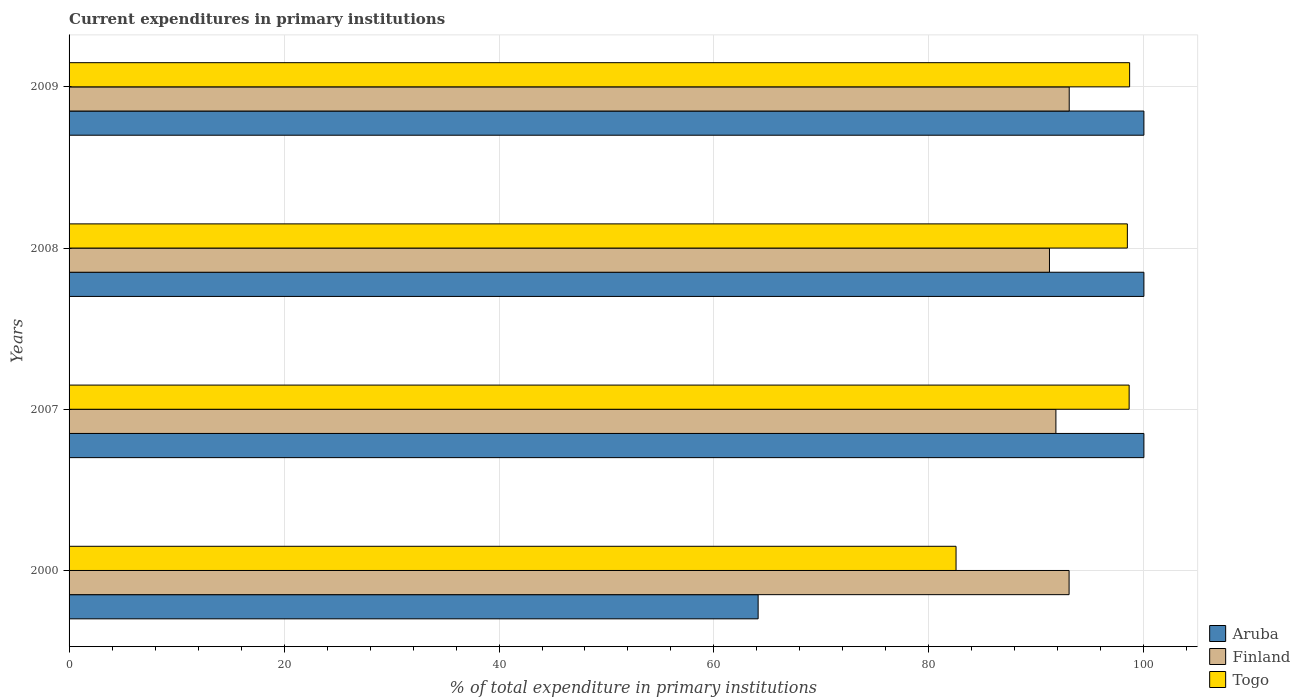Are the number of bars on each tick of the Y-axis equal?
Offer a terse response. Yes. In how many cases, is the number of bars for a given year not equal to the number of legend labels?
Offer a very short reply. 0. Across all years, what is the maximum current expenditures in primary institutions in Aruba?
Your answer should be very brief. 100. Across all years, what is the minimum current expenditures in primary institutions in Aruba?
Keep it short and to the point. 64.11. What is the total current expenditures in primary institutions in Finland in the graph?
Offer a terse response. 369.12. What is the difference between the current expenditures in primary institutions in Aruba in 2007 and that in 2009?
Offer a terse response. 0. What is the difference between the current expenditures in primary institutions in Finland in 2000 and the current expenditures in primary institutions in Aruba in 2008?
Your response must be concise. -6.96. What is the average current expenditures in primary institutions in Togo per year?
Your answer should be compact. 94.57. In the year 2007, what is the difference between the current expenditures in primary institutions in Aruba and current expenditures in primary institutions in Finland?
Your answer should be very brief. 8.19. What is the ratio of the current expenditures in primary institutions in Togo in 2000 to that in 2008?
Provide a short and direct response. 0.84. Is the difference between the current expenditures in primary institutions in Aruba in 2000 and 2009 greater than the difference between the current expenditures in primary institutions in Finland in 2000 and 2009?
Your answer should be compact. No. What is the difference between the highest and the second highest current expenditures in primary institutions in Togo?
Your answer should be compact. 0.04. What is the difference between the highest and the lowest current expenditures in primary institutions in Togo?
Ensure brevity in your answer.  16.15. In how many years, is the current expenditures in primary institutions in Aruba greater than the average current expenditures in primary institutions in Aruba taken over all years?
Provide a succinct answer. 3. What does the 1st bar from the top in 2008 represents?
Keep it short and to the point. Togo. What does the 2nd bar from the bottom in 2008 represents?
Your answer should be very brief. Finland. Is it the case that in every year, the sum of the current expenditures in primary institutions in Togo and current expenditures in primary institutions in Finland is greater than the current expenditures in primary institutions in Aruba?
Make the answer very short. Yes. How many bars are there?
Offer a very short reply. 12. How many years are there in the graph?
Provide a short and direct response. 4. What is the difference between two consecutive major ticks on the X-axis?
Keep it short and to the point. 20. Are the values on the major ticks of X-axis written in scientific E-notation?
Ensure brevity in your answer.  No. Where does the legend appear in the graph?
Your response must be concise. Bottom right. How many legend labels are there?
Offer a terse response. 3. What is the title of the graph?
Offer a terse response. Current expenditures in primary institutions. Does "United States" appear as one of the legend labels in the graph?
Your answer should be compact. No. What is the label or title of the X-axis?
Provide a short and direct response. % of total expenditure in primary institutions. What is the % of total expenditure in primary institutions in Aruba in 2000?
Offer a very short reply. 64.11. What is the % of total expenditure in primary institutions of Finland in 2000?
Keep it short and to the point. 93.04. What is the % of total expenditure in primary institutions of Togo in 2000?
Your answer should be compact. 82.52. What is the % of total expenditure in primary institutions of Aruba in 2007?
Your response must be concise. 100. What is the % of total expenditure in primary institutions in Finland in 2007?
Your response must be concise. 91.81. What is the % of total expenditure in primary institutions in Togo in 2007?
Give a very brief answer. 98.63. What is the % of total expenditure in primary institutions in Aruba in 2008?
Provide a succinct answer. 100. What is the % of total expenditure in primary institutions in Finland in 2008?
Offer a terse response. 91.21. What is the % of total expenditure in primary institutions in Togo in 2008?
Your answer should be very brief. 98.46. What is the % of total expenditure in primary institutions in Aruba in 2009?
Your response must be concise. 100. What is the % of total expenditure in primary institutions of Finland in 2009?
Give a very brief answer. 93.05. What is the % of total expenditure in primary institutions in Togo in 2009?
Your answer should be very brief. 98.67. Across all years, what is the maximum % of total expenditure in primary institutions in Finland?
Offer a terse response. 93.05. Across all years, what is the maximum % of total expenditure in primary institutions in Togo?
Keep it short and to the point. 98.67. Across all years, what is the minimum % of total expenditure in primary institutions of Aruba?
Ensure brevity in your answer.  64.11. Across all years, what is the minimum % of total expenditure in primary institutions in Finland?
Give a very brief answer. 91.21. Across all years, what is the minimum % of total expenditure in primary institutions of Togo?
Offer a very short reply. 82.52. What is the total % of total expenditure in primary institutions of Aruba in the graph?
Your answer should be compact. 364.11. What is the total % of total expenditure in primary institutions of Finland in the graph?
Offer a very short reply. 369.12. What is the total % of total expenditure in primary institutions in Togo in the graph?
Ensure brevity in your answer.  378.28. What is the difference between the % of total expenditure in primary institutions in Aruba in 2000 and that in 2007?
Your answer should be very brief. -35.89. What is the difference between the % of total expenditure in primary institutions in Finland in 2000 and that in 2007?
Your answer should be very brief. 1.23. What is the difference between the % of total expenditure in primary institutions of Togo in 2000 and that in 2007?
Keep it short and to the point. -16.11. What is the difference between the % of total expenditure in primary institutions of Aruba in 2000 and that in 2008?
Give a very brief answer. -35.89. What is the difference between the % of total expenditure in primary institutions in Finland in 2000 and that in 2008?
Your answer should be very brief. 1.83. What is the difference between the % of total expenditure in primary institutions in Togo in 2000 and that in 2008?
Give a very brief answer. -15.94. What is the difference between the % of total expenditure in primary institutions in Aruba in 2000 and that in 2009?
Your response must be concise. -35.89. What is the difference between the % of total expenditure in primary institutions of Finland in 2000 and that in 2009?
Provide a short and direct response. -0.01. What is the difference between the % of total expenditure in primary institutions of Togo in 2000 and that in 2009?
Offer a terse response. -16.15. What is the difference between the % of total expenditure in primary institutions in Finland in 2007 and that in 2008?
Make the answer very short. 0.6. What is the difference between the % of total expenditure in primary institutions of Togo in 2007 and that in 2008?
Provide a succinct answer. 0.17. What is the difference between the % of total expenditure in primary institutions of Aruba in 2007 and that in 2009?
Make the answer very short. 0. What is the difference between the % of total expenditure in primary institutions of Finland in 2007 and that in 2009?
Ensure brevity in your answer.  -1.24. What is the difference between the % of total expenditure in primary institutions of Togo in 2007 and that in 2009?
Provide a succinct answer. -0.04. What is the difference between the % of total expenditure in primary institutions in Finland in 2008 and that in 2009?
Ensure brevity in your answer.  -1.84. What is the difference between the % of total expenditure in primary institutions of Togo in 2008 and that in 2009?
Provide a short and direct response. -0.21. What is the difference between the % of total expenditure in primary institutions of Aruba in 2000 and the % of total expenditure in primary institutions of Finland in 2007?
Provide a succinct answer. -27.7. What is the difference between the % of total expenditure in primary institutions of Aruba in 2000 and the % of total expenditure in primary institutions of Togo in 2007?
Ensure brevity in your answer.  -34.52. What is the difference between the % of total expenditure in primary institutions of Finland in 2000 and the % of total expenditure in primary institutions of Togo in 2007?
Make the answer very short. -5.59. What is the difference between the % of total expenditure in primary institutions of Aruba in 2000 and the % of total expenditure in primary institutions of Finland in 2008?
Provide a short and direct response. -27.1. What is the difference between the % of total expenditure in primary institutions in Aruba in 2000 and the % of total expenditure in primary institutions in Togo in 2008?
Keep it short and to the point. -34.35. What is the difference between the % of total expenditure in primary institutions of Finland in 2000 and the % of total expenditure in primary institutions of Togo in 2008?
Offer a terse response. -5.42. What is the difference between the % of total expenditure in primary institutions of Aruba in 2000 and the % of total expenditure in primary institutions of Finland in 2009?
Make the answer very short. -28.94. What is the difference between the % of total expenditure in primary institutions in Aruba in 2000 and the % of total expenditure in primary institutions in Togo in 2009?
Make the answer very short. -34.56. What is the difference between the % of total expenditure in primary institutions in Finland in 2000 and the % of total expenditure in primary institutions in Togo in 2009?
Keep it short and to the point. -5.63. What is the difference between the % of total expenditure in primary institutions of Aruba in 2007 and the % of total expenditure in primary institutions of Finland in 2008?
Your response must be concise. 8.79. What is the difference between the % of total expenditure in primary institutions of Aruba in 2007 and the % of total expenditure in primary institutions of Togo in 2008?
Make the answer very short. 1.54. What is the difference between the % of total expenditure in primary institutions of Finland in 2007 and the % of total expenditure in primary institutions of Togo in 2008?
Your answer should be very brief. -6.65. What is the difference between the % of total expenditure in primary institutions of Aruba in 2007 and the % of total expenditure in primary institutions of Finland in 2009?
Your answer should be very brief. 6.95. What is the difference between the % of total expenditure in primary institutions in Aruba in 2007 and the % of total expenditure in primary institutions in Togo in 2009?
Your answer should be compact. 1.33. What is the difference between the % of total expenditure in primary institutions in Finland in 2007 and the % of total expenditure in primary institutions in Togo in 2009?
Your response must be concise. -6.86. What is the difference between the % of total expenditure in primary institutions of Aruba in 2008 and the % of total expenditure in primary institutions of Finland in 2009?
Keep it short and to the point. 6.95. What is the difference between the % of total expenditure in primary institutions of Aruba in 2008 and the % of total expenditure in primary institutions of Togo in 2009?
Make the answer very short. 1.33. What is the difference between the % of total expenditure in primary institutions in Finland in 2008 and the % of total expenditure in primary institutions in Togo in 2009?
Give a very brief answer. -7.46. What is the average % of total expenditure in primary institutions of Aruba per year?
Ensure brevity in your answer.  91.03. What is the average % of total expenditure in primary institutions in Finland per year?
Your response must be concise. 92.28. What is the average % of total expenditure in primary institutions in Togo per year?
Your answer should be very brief. 94.57. In the year 2000, what is the difference between the % of total expenditure in primary institutions in Aruba and % of total expenditure in primary institutions in Finland?
Offer a terse response. -28.93. In the year 2000, what is the difference between the % of total expenditure in primary institutions of Aruba and % of total expenditure in primary institutions of Togo?
Provide a short and direct response. -18.41. In the year 2000, what is the difference between the % of total expenditure in primary institutions in Finland and % of total expenditure in primary institutions in Togo?
Provide a short and direct response. 10.52. In the year 2007, what is the difference between the % of total expenditure in primary institutions of Aruba and % of total expenditure in primary institutions of Finland?
Provide a short and direct response. 8.19. In the year 2007, what is the difference between the % of total expenditure in primary institutions of Aruba and % of total expenditure in primary institutions of Togo?
Offer a very short reply. 1.37. In the year 2007, what is the difference between the % of total expenditure in primary institutions in Finland and % of total expenditure in primary institutions in Togo?
Offer a terse response. -6.81. In the year 2008, what is the difference between the % of total expenditure in primary institutions in Aruba and % of total expenditure in primary institutions in Finland?
Provide a succinct answer. 8.79. In the year 2008, what is the difference between the % of total expenditure in primary institutions in Aruba and % of total expenditure in primary institutions in Togo?
Your answer should be very brief. 1.54. In the year 2008, what is the difference between the % of total expenditure in primary institutions of Finland and % of total expenditure in primary institutions of Togo?
Provide a short and direct response. -7.25. In the year 2009, what is the difference between the % of total expenditure in primary institutions of Aruba and % of total expenditure in primary institutions of Finland?
Your answer should be compact. 6.95. In the year 2009, what is the difference between the % of total expenditure in primary institutions of Aruba and % of total expenditure in primary institutions of Togo?
Your response must be concise. 1.33. In the year 2009, what is the difference between the % of total expenditure in primary institutions in Finland and % of total expenditure in primary institutions in Togo?
Your answer should be very brief. -5.62. What is the ratio of the % of total expenditure in primary institutions in Aruba in 2000 to that in 2007?
Provide a succinct answer. 0.64. What is the ratio of the % of total expenditure in primary institutions in Finland in 2000 to that in 2007?
Ensure brevity in your answer.  1.01. What is the ratio of the % of total expenditure in primary institutions of Togo in 2000 to that in 2007?
Your response must be concise. 0.84. What is the ratio of the % of total expenditure in primary institutions of Aruba in 2000 to that in 2008?
Offer a very short reply. 0.64. What is the ratio of the % of total expenditure in primary institutions in Finland in 2000 to that in 2008?
Your answer should be compact. 1.02. What is the ratio of the % of total expenditure in primary institutions of Togo in 2000 to that in 2008?
Provide a succinct answer. 0.84. What is the ratio of the % of total expenditure in primary institutions of Aruba in 2000 to that in 2009?
Your answer should be compact. 0.64. What is the ratio of the % of total expenditure in primary institutions in Togo in 2000 to that in 2009?
Your answer should be very brief. 0.84. What is the ratio of the % of total expenditure in primary institutions of Aruba in 2007 to that in 2008?
Make the answer very short. 1. What is the ratio of the % of total expenditure in primary institutions of Finland in 2007 to that in 2008?
Offer a very short reply. 1.01. What is the ratio of the % of total expenditure in primary institutions in Aruba in 2007 to that in 2009?
Provide a short and direct response. 1. What is the ratio of the % of total expenditure in primary institutions of Finland in 2007 to that in 2009?
Your answer should be compact. 0.99. What is the ratio of the % of total expenditure in primary institutions in Aruba in 2008 to that in 2009?
Your answer should be very brief. 1. What is the ratio of the % of total expenditure in primary institutions in Finland in 2008 to that in 2009?
Keep it short and to the point. 0.98. What is the ratio of the % of total expenditure in primary institutions of Togo in 2008 to that in 2009?
Keep it short and to the point. 1. What is the difference between the highest and the second highest % of total expenditure in primary institutions of Aruba?
Your answer should be very brief. 0. What is the difference between the highest and the second highest % of total expenditure in primary institutions of Finland?
Ensure brevity in your answer.  0.01. What is the difference between the highest and the second highest % of total expenditure in primary institutions of Togo?
Give a very brief answer. 0.04. What is the difference between the highest and the lowest % of total expenditure in primary institutions in Aruba?
Provide a succinct answer. 35.89. What is the difference between the highest and the lowest % of total expenditure in primary institutions in Finland?
Your answer should be very brief. 1.84. What is the difference between the highest and the lowest % of total expenditure in primary institutions in Togo?
Give a very brief answer. 16.15. 